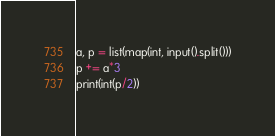Convert code to text. <code><loc_0><loc_0><loc_500><loc_500><_Python_>a, p = list(map(int, input().split()))
p += a*3
print(int(p/2))
</code> 